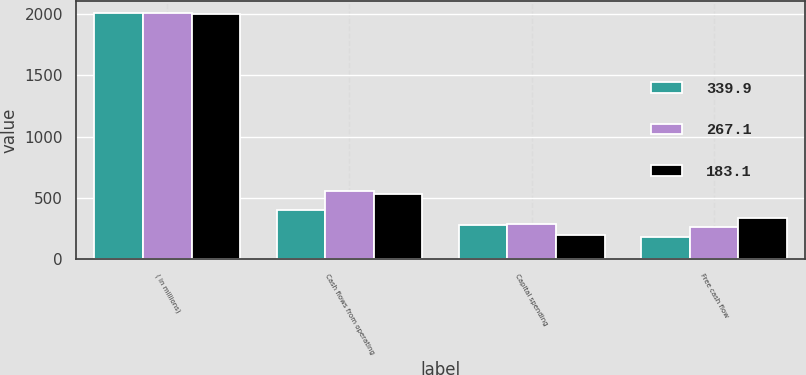<chart> <loc_0><loc_0><loc_500><loc_500><stacked_bar_chart><ecel><fcel>( in millions)<fcel>Cash flows from operating<fcel>Capital spending<fcel>Free cash flow<nl><fcel>339.9<fcel>2006<fcel>401.4<fcel>279.6<fcel>183.1<nl><fcel>267.1<fcel>2005<fcel>558.8<fcel>291.7<fcel>267.1<nl><fcel>183.1<fcel>2004<fcel>535.9<fcel>196<fcel>339.9<nl></chart> 